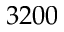<formula> <loc_0><loc_0><loc_500><loc_500>3 2 0 0</formula> 